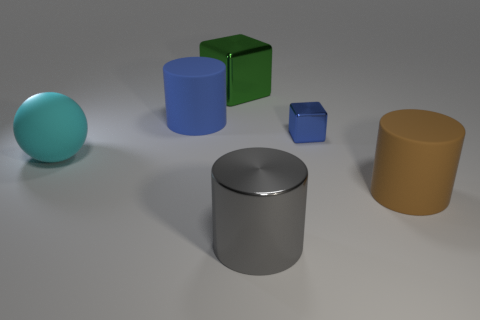Subtract all large blue matte cylinders. How many cylinders are left? 2 Subtract all brown cylinders. How many cylinders are left? 2 Subtract all balls. How many objects are left? 5 Subtract 1 cubes. How many cubes are left? 1 Subtract all purple cylinders. Subtract all cyan blocks. How many cylinders are left? 3 Subtract all gray cylinders. How many blue cubes are left? 1 Subtract all blue metal things. Subtract all gray metal things. How many objects are left? 4 Add 5 large gray cylinders. How many large gray cylinders are left? 6 Add 2 tiny blocks. How many tiny blocks exist? 3 Add 1 cyan things. How many objects exist? 7 